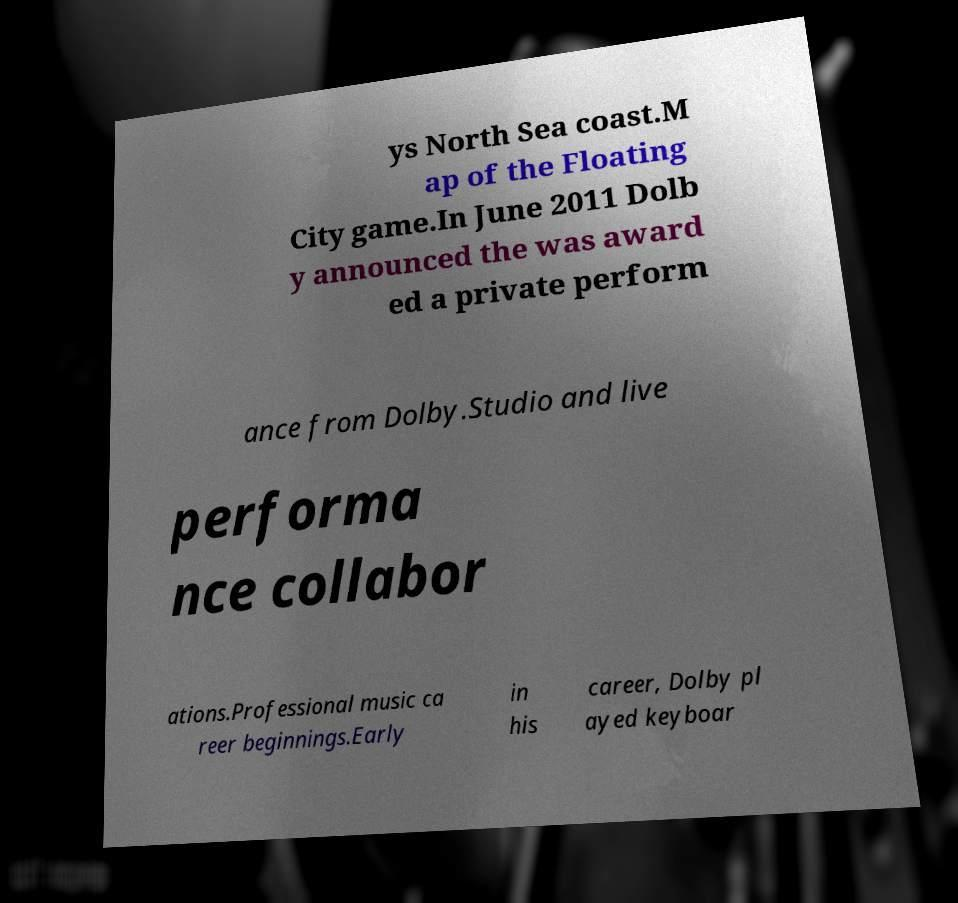Could you extract and type out the text from this image? ys North Sea coast.M ap of the Floating City game.In June 2011 Dolb y announced the was award ed a private perform ance from Dolby.Studio and live performa nce collabor ations.Professional music ca reer beginnings.Early in his career, Dolby pl ayed keyboar 